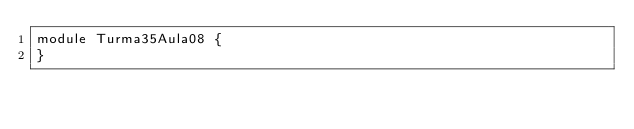Convert code to text. <code><loc_0><loc_0><loc_500><loc_500><_Java_>module Turma35Aula08 {
}</code> 